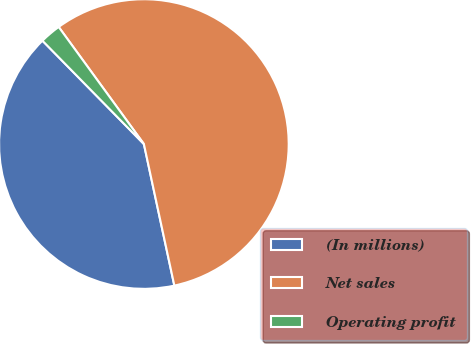Convert chart to OTSL. <chart><loc_0><loc_0><loc_500><loc_500><pie_chart><fcel>(In millions)<fcel>Net sales<fcel>Operating profit<nl><fcel>41.02%<fcel>56.64%<fcel>2.34%<nl></chart> 